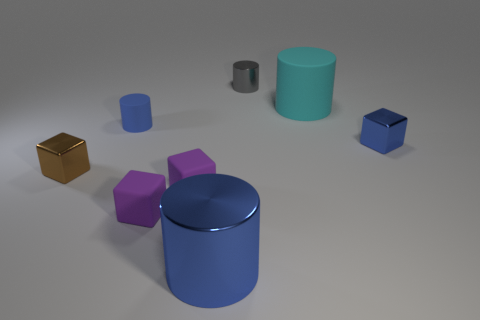Subtract all blue blocks. How many blocks are left? 3 Add 1 cyan shiny things. How many objects exist? 9 Subtract all cyan cylinders. How many cylinders are left? 3 Subtract 1 cylinders. How many cylinders are left? 3 Subtract 0 gray blocks. How many objects are left? 8 Subtract all purple blocks. Subtract all purple balls. How many blocks are left? 2 Subtract all brown cylinders. How many blue cubes are left? 1 Subtract all large blue things. Subtract all cyan objects. How many objects are left? 6 Add 3 big metallic cylinders. How many big metallic cylinders are left? 4 Add 6 tiny gray metallic things. How many tiny gray metallic things exist? 7 